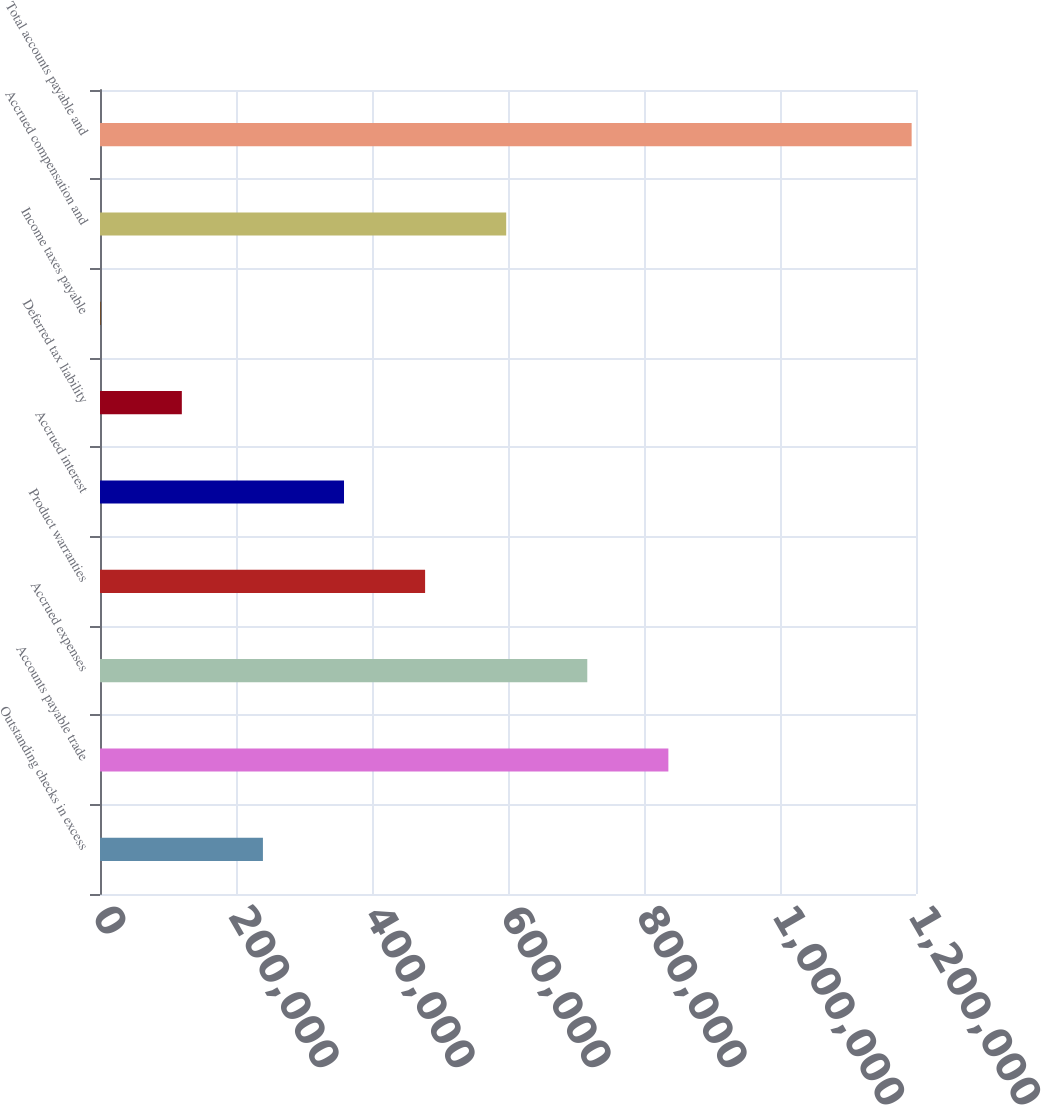Convert chart to OTSL. <chart><loc_0><loc_0><loc_500><loc_500><bar_chart><fcel>Outstanding checks in excess<fcel>Accounts payable trade<fcel>Accrued expenses<fcel>Product warranties<fcel>Accrued interest<fcel>Deferred tax liability<fcel>Income taxes payable<fcel>Accrued compensation and<fcel>Total accounts payable and<nl><fcel>239595<fcel>835844<fcel>716594<fcel>478094<fcel>358844<fcel>120345<fcel>1095<fcel>597344<fcel>1.19359e+06<nl></chart> 